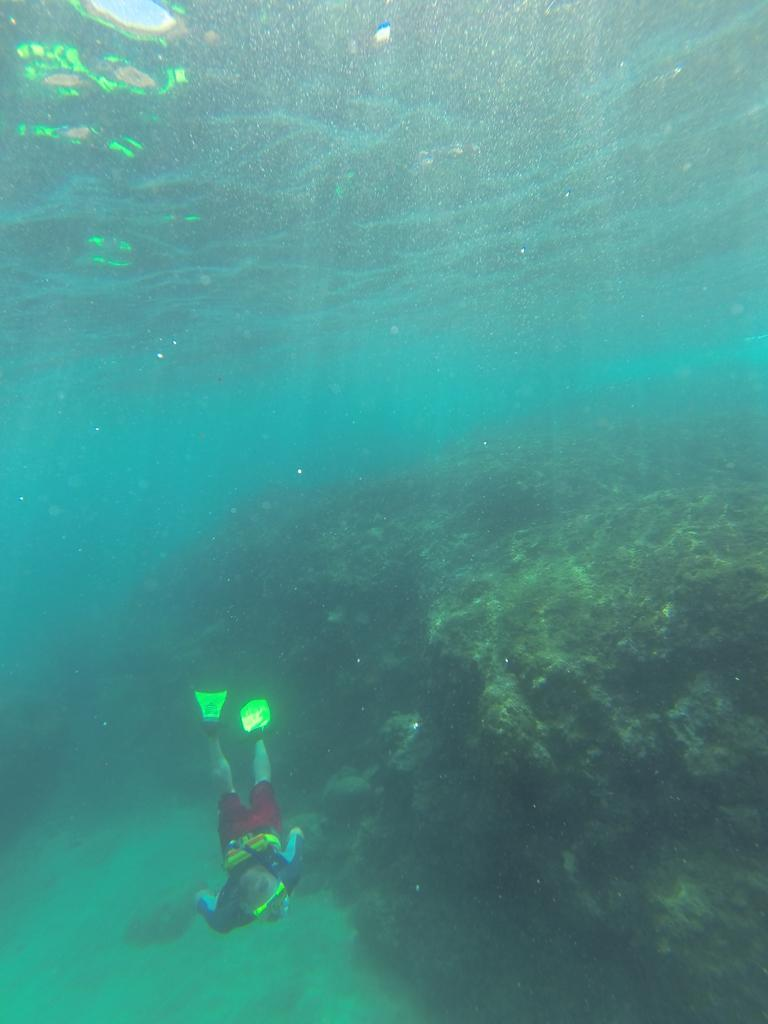What type of environment is depicted in the image? The image is an underwater picture. What activity is the person in the image engaged in? There is a person swimming in the image. What large object can be seen in the image? There is a huge rock in the image. What color is the rock in the image? The rock is green in color. What type of rice can be seen growing near the person swimming in the image? There is no rice present in the image, as it is an underwater scene. 